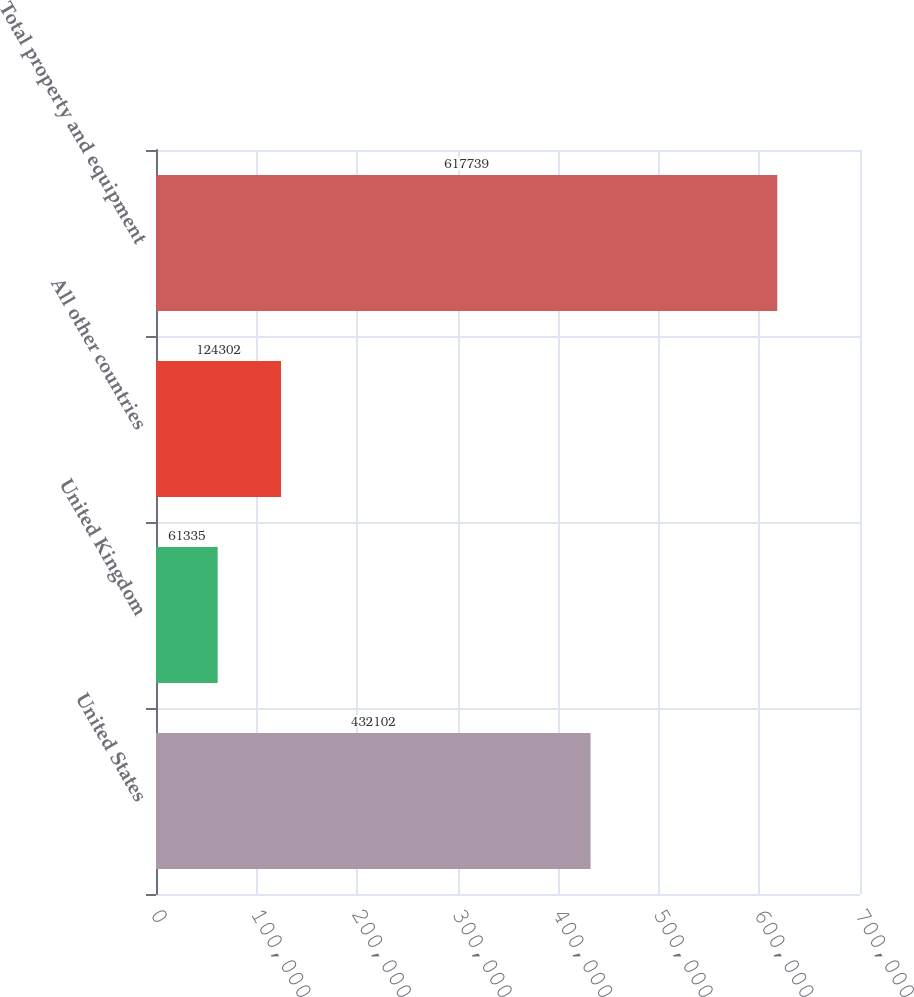Convert chart to OTSL. <chart><loc_0><loc_0><loc_500><loc_500><bar_chart><fcel>United States<fcel>United Kingdom<fcel>All other countries<fcel>Total property and equipment<nl><fcel>432102<fcel>61335<fcel>124302<fcel>617739<nl></chart> 